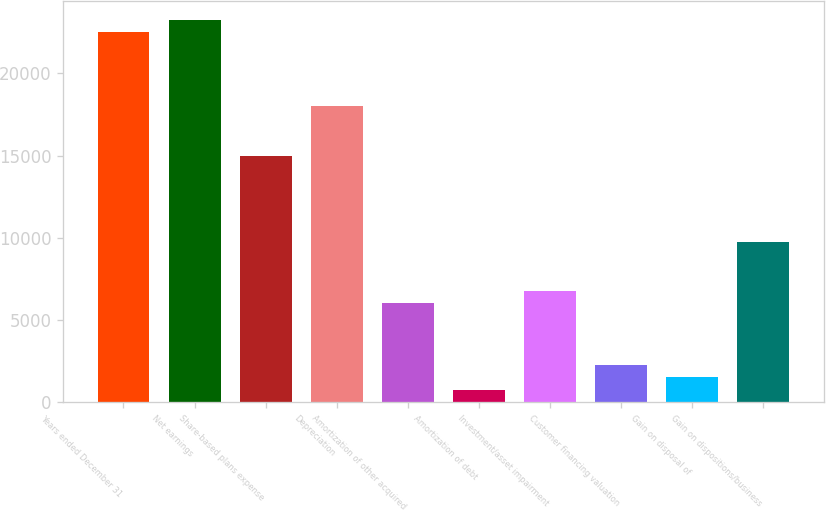Convert chart. <chart><loc_0><loc_0><loc_500><loc_500><bar_chart><fcel>Years ended December 31<fcel>Net earnings<fcel>Share-based plans expense<fcel>Depreciation<fcel>Amortization of other acquired<fcel>Amortization of debt<fcel>Investment/asset impairment<fcel>Customer financing valuation<fcel>Gain on disposal of<fcel>Gain on dispositions/business<nl><fcel>22495<fcel>23244.8<fcel>14997<fcel>17996.2<fcel>5999.4<fcel>750.8<fcel>6749.2<fcel>2250.4<fcel>1500.6<fcel>9748.4<nl></chart> 